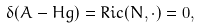<formula> <loc_0><loc_0><loc_500><loc_500>\delta ( A - H g ) = R i c ( N , \cdot ) = 0 ,</formula> 